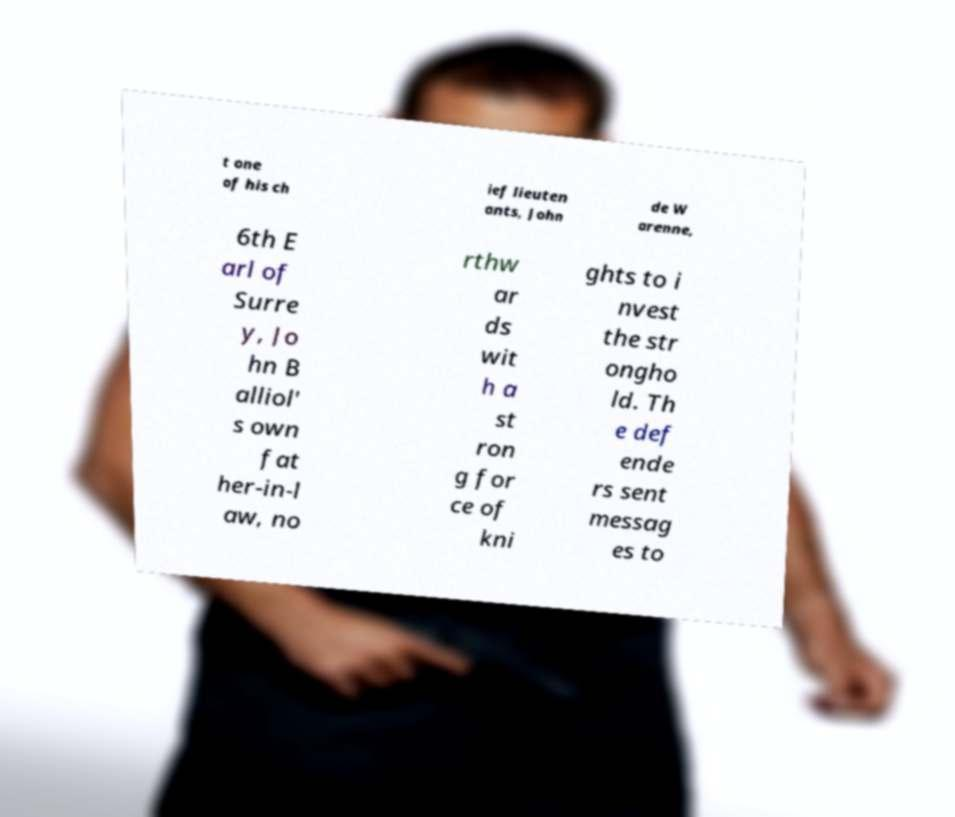Please read and relay the text visible in this image. What does it say? t one of his ch ief lieuten ants, John de W arenne, 6th E arl of Surre y, Jo hn B alliol' s own fat her-in-l aw, no rthw ar ds wit h a st ron g for ce of kni ghts to i nvest the str ongho ld. Th e def ende rs sent messag es to 